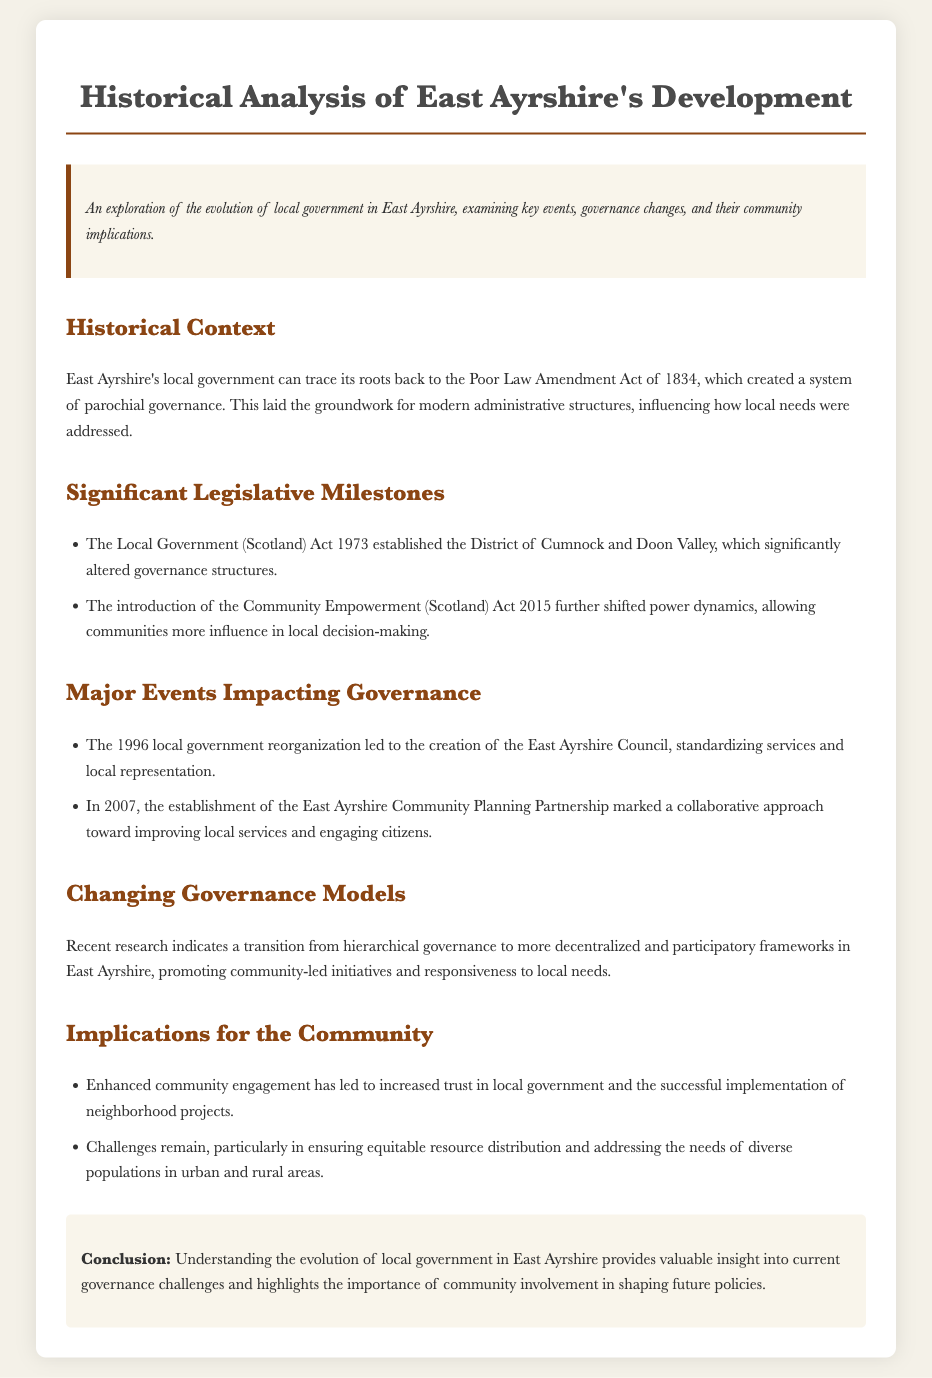What act laid the groundwork for modern administrative structures in East Ayrshire? The Poor Law Amendment Act of 1834 is mentioned as the act that created a system of parochial governance, influencing modern administrative structures.
Answer: Poor Law Amendment Act of 1834 What year was the Local Government (Scotland) Act passed? The Local Government (Scotland) Act 1973 is noted in the document, indicating its year of enactment.
Answer: 1973 What major change occurred in East Ayrshire in 1996? It states that the 1996 local government reorganization led to the creation of the East Ayrshire Council, signifying a significant governance change.
Answer: Creation of East Ayrshire Council What does the establishment of the East Ayrshire Community Planning Partnership in 2007 signify? The document mentions that this event marked a collaborative approach toward improving local services and engaging citizens.
Answer: Collaborative approach Which act shifted power dynamics towards community decision-making? The introduction of the Community Empowerment (Scotland) Act 2015 allowed communities more influence in local decision-making according to the document.
Answer: Community Empowerment (Scotland) Act 2015 What type of governance model is becoming more prominent in East Ayrshire? The document discusses a transition toward decentralized and participatory frameworks.
Answer: Decentralized and participatory frameworks What is one community implication mentioned in relation to enhanced engagement? The text states that enhanced community engagement has led to increased trust in local government and successful neighborhood projects.
Answer: Increased trust What challenge remains in East Ayrshire's local governance? The document points out challenges in ensuring equitable resource distribution across diverse populations in urban and rural areas.
Answer: Equitable resource distribution 